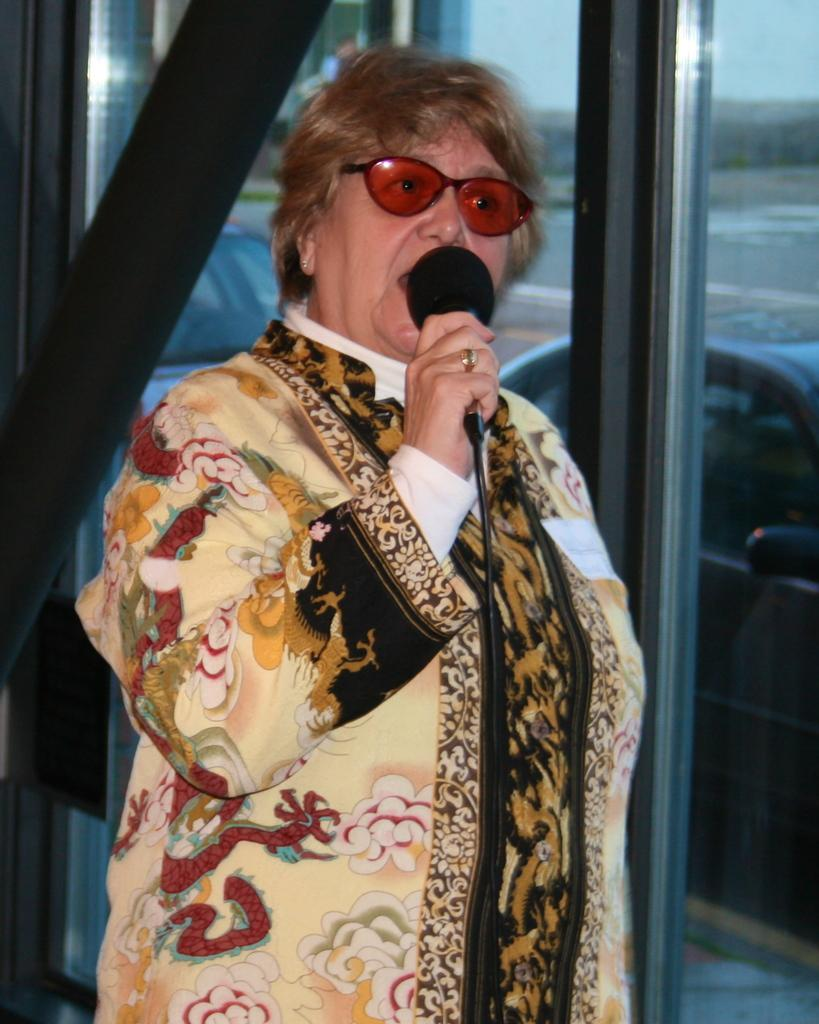Who is the main subject in the image? There is a woman in the image. What is the woman doing in the image? The woman is standing and holding a microphone. What accessories is the woman wearing in the image? The woman is wearing shades and a dress. What can be seen in the background of the image? There are vehicles in the background of the image. What time of day is it in the image, and is the woman's father present? The time of day is not mentioned in the image, and there is no information about the woman's father being present. Is there a fire visible in the image? No, there is no fire present in the image. 